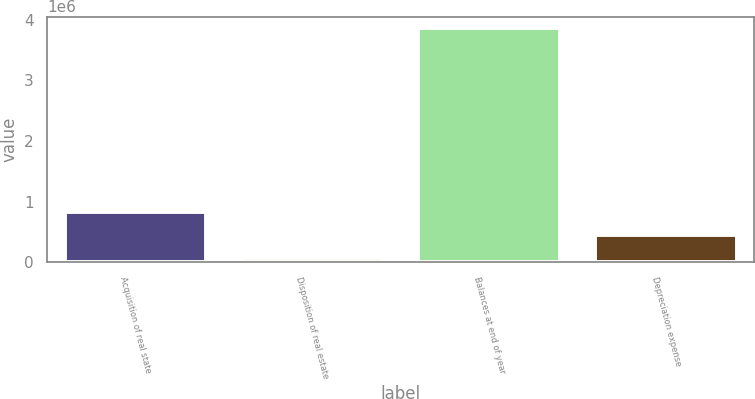Convert chart to OTSL. <chart><loc_0><loc_0><loc_500><loc_500><bar_chart><fcel>Acquisition of real state<fcel>Disposition of real estate<fcel>Balances at end of year<fcel>Depreciation expense<nl><fcel>825627<fcel>68048<fcel>3.85594e+06<fcel>446837<nl></chart> 